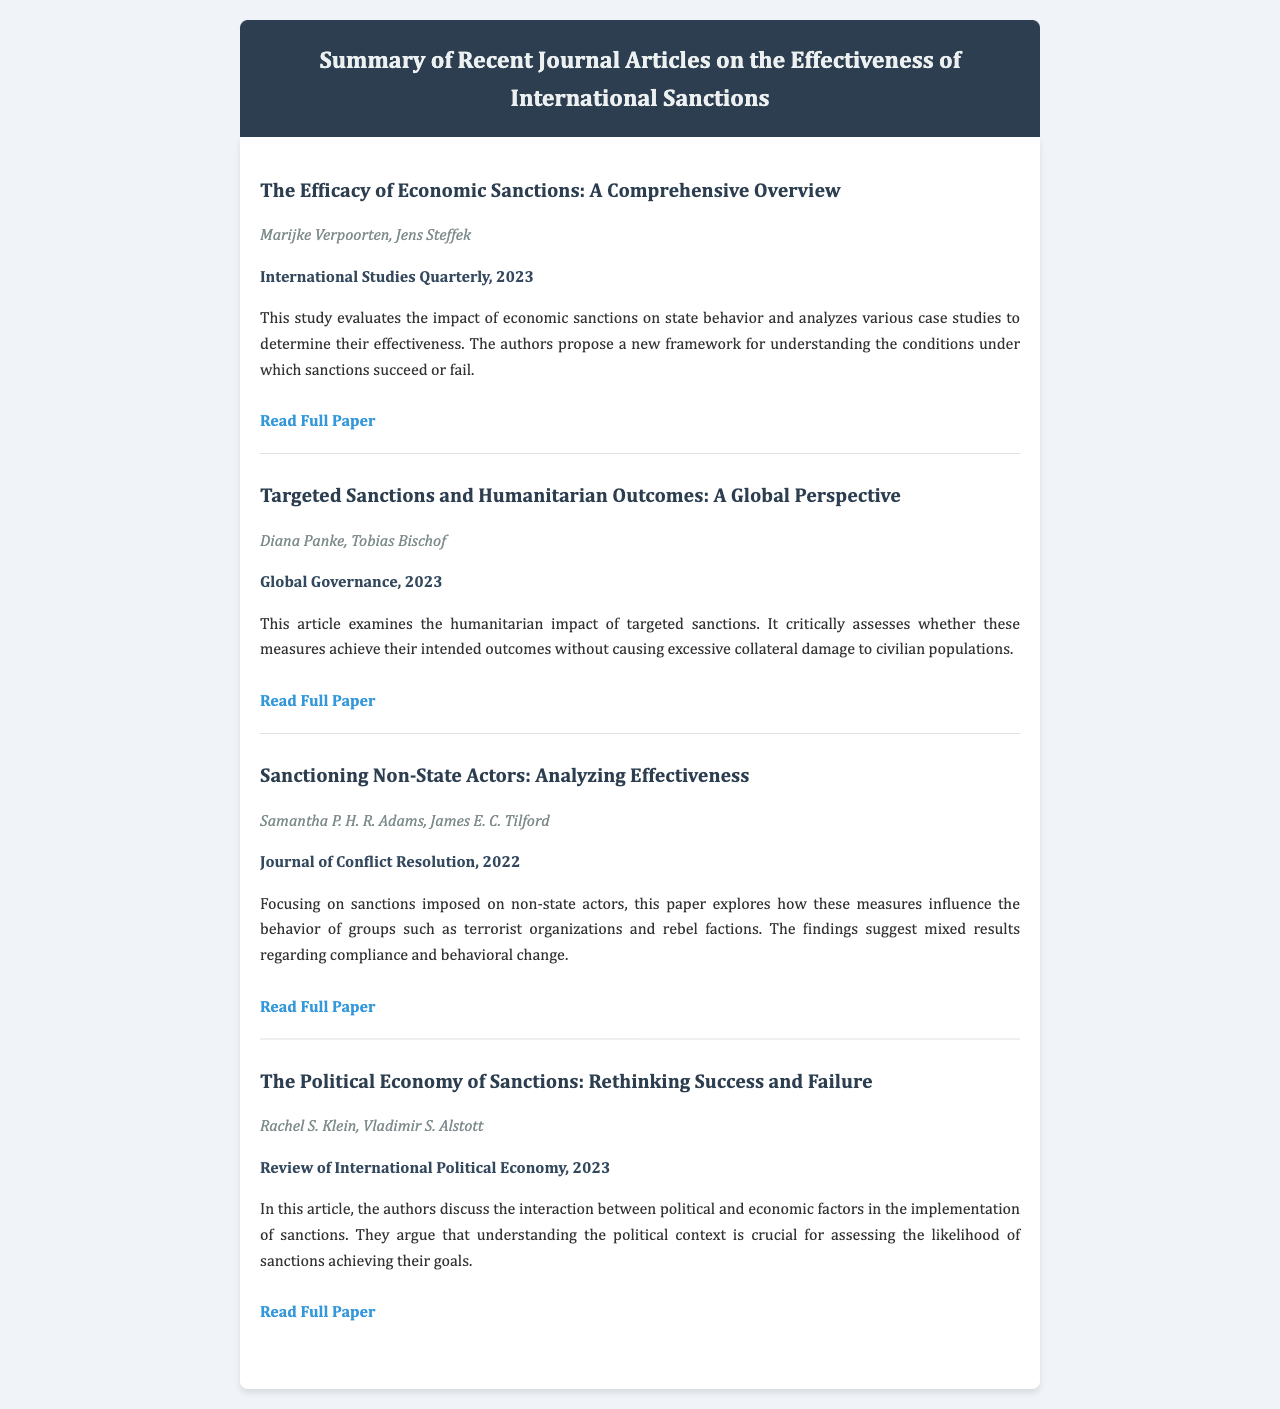What is the title of the first article? The title of the first article is included in the document under the first article section.
Answer: The Efficacy of Economic Sanctions: A Comprehensive Overview Who are the authors of the article on targeted sanctions? The authors' names are presented in italics beneath the title and journal information for the article on targeted sanctions.
Answer: Diana Panke, Tobias Bischof In which journal was the article "Sanctioning Non-State Actors" published? The journal name is bolded and presented under the authors’ names for each article.
Answer: Journal of Conflict Resolution What year was "The Political Economy of Sanctions" published? The year of publication is provided after the journal title for each article.
Answer: 2023 What is the main focus of Samantha P. H. R. Adams's article? The summary provided under the article outlines the main focus of the research.
Answer: Sanctions imposed on non-state actors What is the total number of articles summarized? Counting the articles listed in the document would provide the answer to this question.
Answer: Four What critical aspect does the article by Rachel S. Klein discuss? The summary of the article points out the topic discussed regarding political and economic factors.
Answer: Interaction between political and economic factors Which article addresses the humanitarian impact of sanctions? The title of the article is mentioned explicitly in the document under the respective section.
Answer: Targeted Sanctions and Humanitarian Outcomes: A Global Perspective 